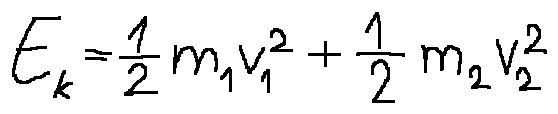Convert formula to latex. <formula><loc_0><loc_0><loc_500><loc_500>E _ { k } = \frac { 1 } { 2 } m _ { 1 } v _ { 1 } ^ { 2 } + \frac { 1 } { 2 } m _ { 2 } v _ { 2 } ^ { 2 }</formula> 